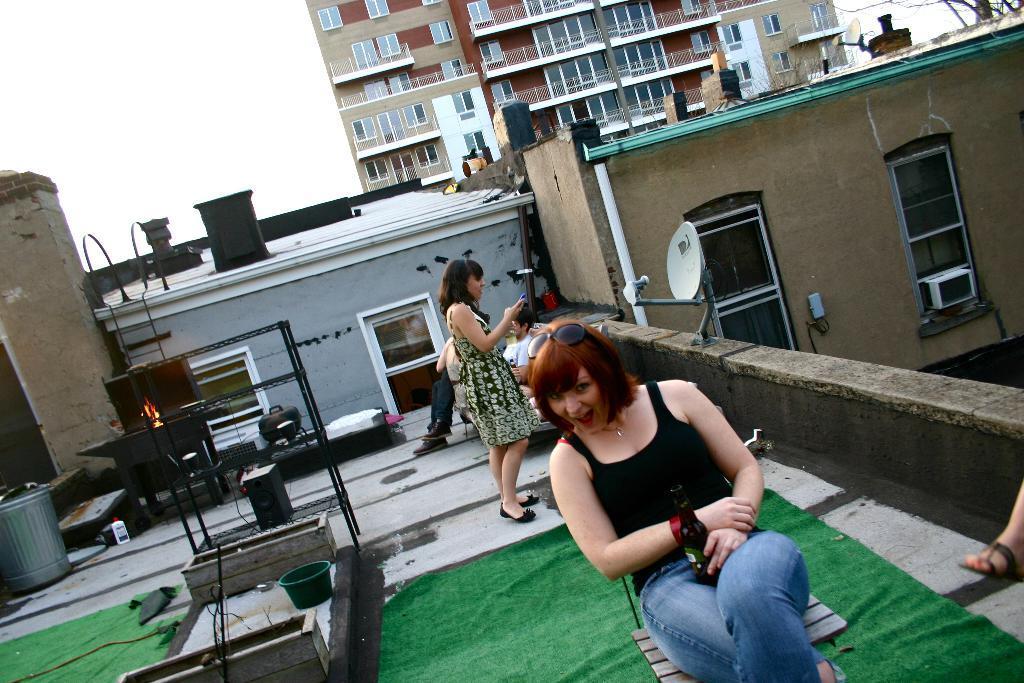Can you describe this image briefly? A beautiful woman is sitting on the chair, she wore a black color top and a blue color jeans. Behind her there is a woman standing and there are buildings in the right side of an image. 